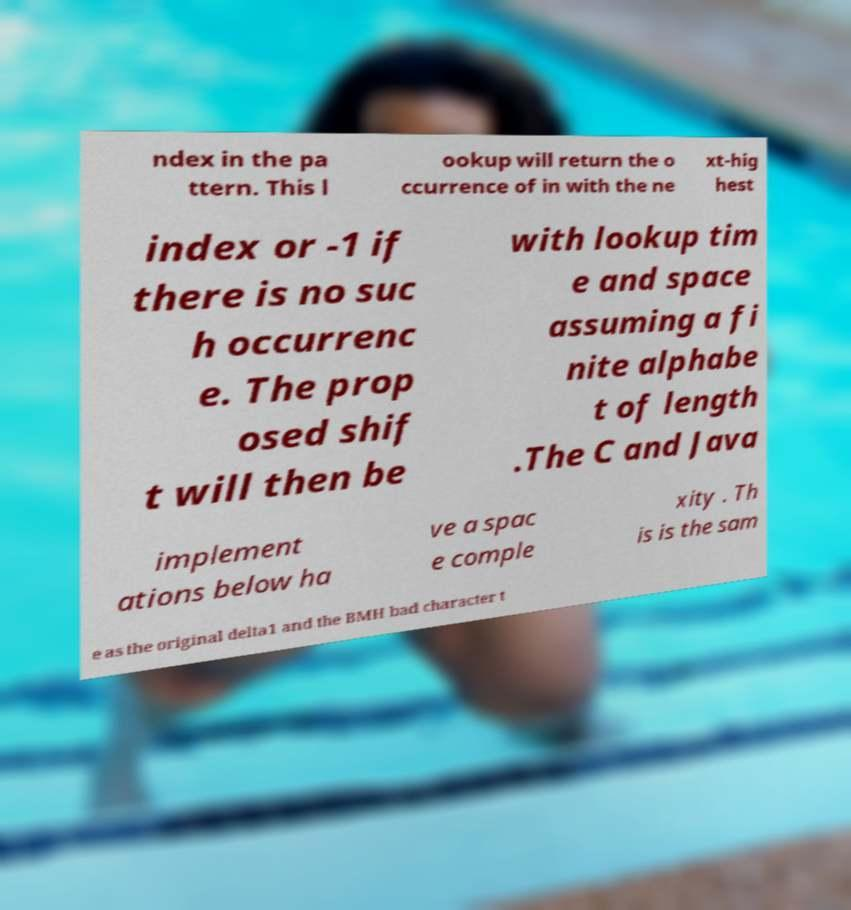Could you extract and type out the text from this image? ndex in the pa ttern. This l ookup will return the o ccurrence of in with the ne xt-hig hest index or -1 if there is no suc h occurrenc e. The prop osed shif t will then be with lookup tim e and space assuming a fi nite alphabe t of length .The C and Java implement ations below ha ve a spac e comple xity . Th is is the sam e as the original delta1 and the BMH bad character t 